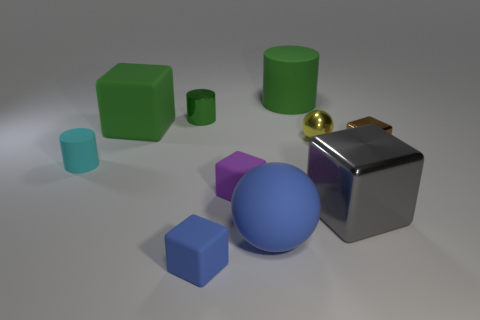What number of objects are cyan matte things or rubber blocks that are behind the blue matte sphere?
Offer a terse response. 3. What material is the small blue thing?
Offer a terse response. Rubber. Is there anything else of the same color as the small metallic sphere?
Keep it short and to the point. No. Is the small cyan thing the same shape as the brown metal thing?
Your answer should be very brief. No. How big is the metal object that is to the left of the small yellow sphere that is behind the large matte thing that is in front of the brown object?
Offer a terse response. Small. What number of other objects are the same material as the small blue cube?
Provide a short and direct response. 5. There is a sphere to the left of the big green cylinder; what is its color?
Offer a very short reply. Blue. What is the material of the tiny cube right of the metal thing in front of the small metal thing that is on the right side of the large metal thing?
Your answer should be very brief. Metal. Are there any matte objects that have the same shape as the green metallic thing?
Your response must be concise. Yes. There is a gray metallic thing that is the same size as the green rubber block; what shape is it?
Keep it short and to the point. Cube. 